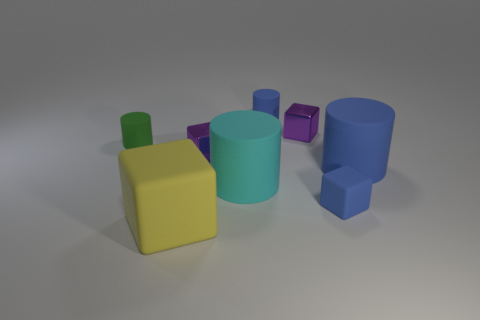What colors are present in the objects shown in the image? The objects in the image exhibit several colors including light blue, darker blue, green, yellow, and purple. Each object's color gives it a distinct appearance. 